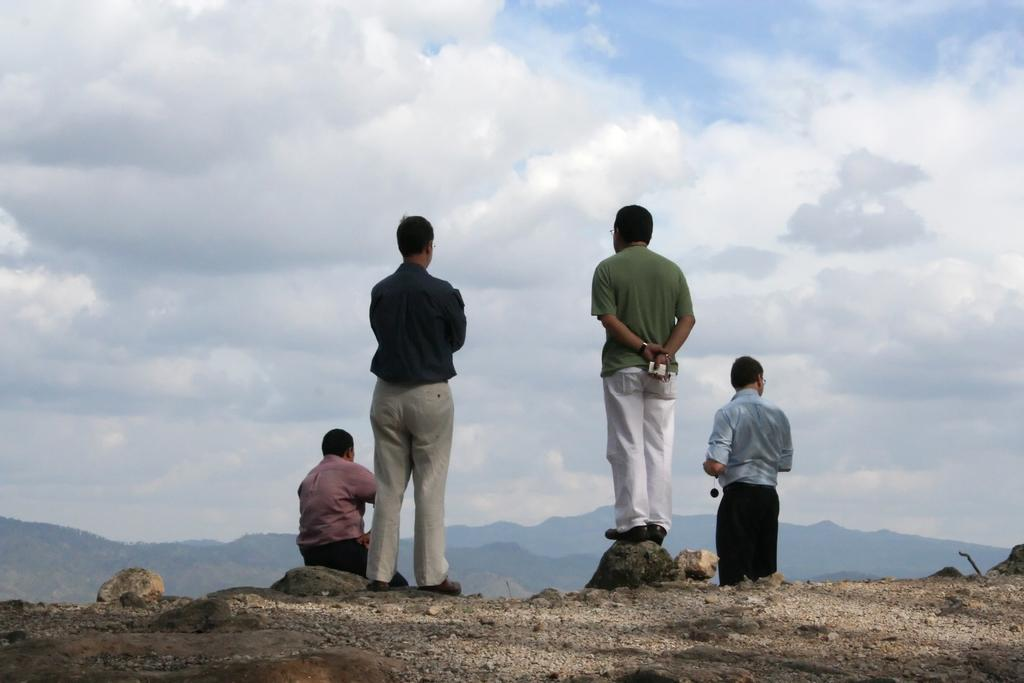How many people are in the image? There are four men in the image. What can be seen in the background of the image? There is a sky with clouds and mountains in the background of the image. What is visible at the bottom of the image? The land is visible at the bottom of the image. What type of soda is being served in the image? There is no soda present in the image. Is the ball being used by any of the men in the image? There is no ball present in the image. 